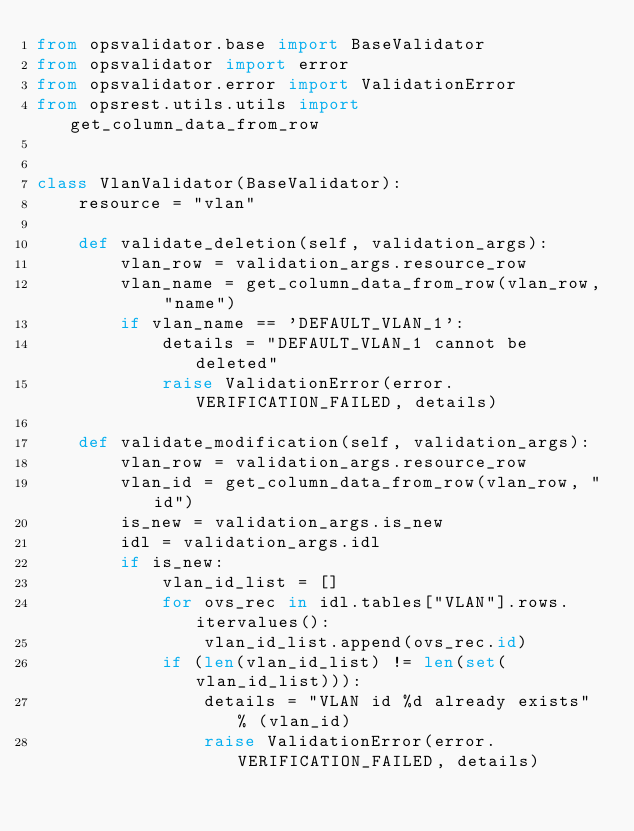<code> <loc_0><loc_0><loc_500><loc_500><_Python_>from opsvalidator.base import BaseValidator
from opsvalidator import error
from opsvalidator.error import ValidationError
from opsrest.utils.utils import get_column_data_from_row


class VlanValidator(BaseValidator):
    resource = "vlan"

    def validate_deletion(self, validation_args):
        vlan_row = validation_args.resource_row
        vlan_name = get_column_data_from_row(vlan_row, "name")
        if vlan_name == 'DEFAULT_VLAN_1':
            details = "DEFAULT_VLAN_1 cannot be deleted"
            raise ValidationError(error.VERIFICATION_FAILED, details)

    def validate_modification(self, validation_args):
        vlan_row = validation_args.resource_row
        vlan_id = get_column_data_from_row(vlan_row, "id")
        is_new = validation_args.is_new
        idl = validation_args.idl
        if is_new:
            vlan_id_list = []
            for ovs_rec in idl.tables["VLAN"].rows.itervalues():
                vlan_id_list.append(ovs_rec.id)
            if (len(vlan_id_list) != len(set(vlan_id_list))):
                details = "VLAN id %d already exists" % (vlan_id)
                raise ValidationError(error.VERIFICATION_FAILED, details)
</code> 